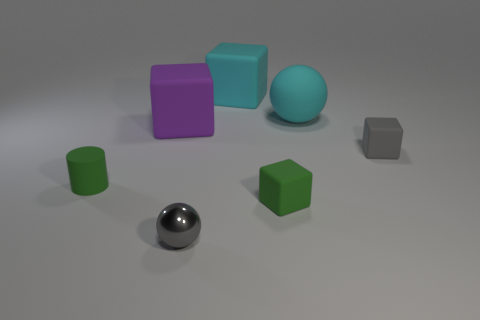Add 3 purple metal cylinders. How many objects exist? 10 Subtract all large purple cubes. How many cubes are left? 3 Subtract all spheres. How many objects are left? 5 Subtract all purple blocks. How many blocks are left? 3 Subtract 3 blocks. How many blocks are left? 1 Subtract all gray spheres. Subtract all brown cylinders. How many spheres are left? 1 Subtract all big cyan cubes. Subtract all tiny blue objects. How many objects are left? 6 Add 5 tiny spheres. How many tiny spheres are left? 6 Add 4 tiny green objects. How many tiny green objects exist? 6 Subtract 0 cyan cylinders. How many objects are left? 7 